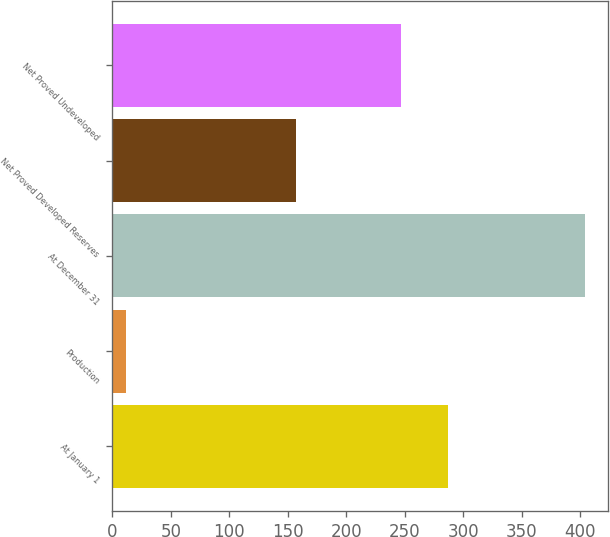Convert chart. <chart><loc_0><loc_0><loc_500><loc_500><bar_chart><fcel>At January 1<fcel>Production<fcel>At December 31<fcel>Net Proved Developed Reserves<fcel>Net Proved Undeveloped<nl><fcel>287<fcel>12<fcel>404<fcel>157<fcel>247<nl></chart> 